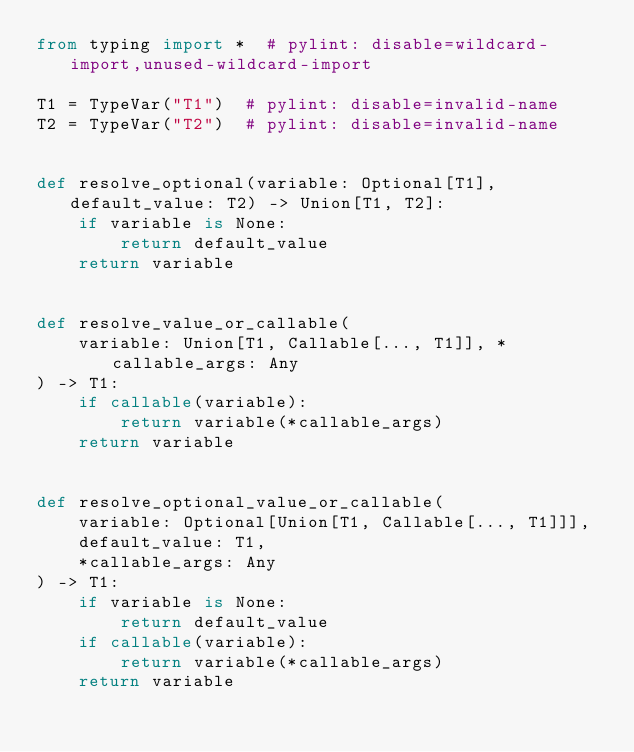Convert code to text. <code><loc_0><loc_0><loc_500><loc_500><_Python_>from typing import *  # pylint: disable=wildcard-import,unused-wildcard-import

T1 = TypeVar("T1")  # pylint: disable=invalid-name
T2 = TypeVar("T2")  # pylint: disable=invalid-name


def resolve_optional(variable: Optional[T1], default_value: T2) -> Union[T1, T2]:
    if variable is None:
        return default_value
    return variable


def resolve_value_or_callable(
    variable: Union[T1, Callable[..., T1]], *callable_args: Any
) -> T1:
    if callable(variable):
        return variable(*callable_args)
    return variable


def resolve_optional_value_or_callable(
    variable: Optional[Union[T1, Callable[..., T1]]],
    default_value: T1,
    *callable_args: Any
) -> T1:
    if variable is None:
        return default_value
    if callable(variable):
        return variable(*callable_args)
    return variable
</code> 